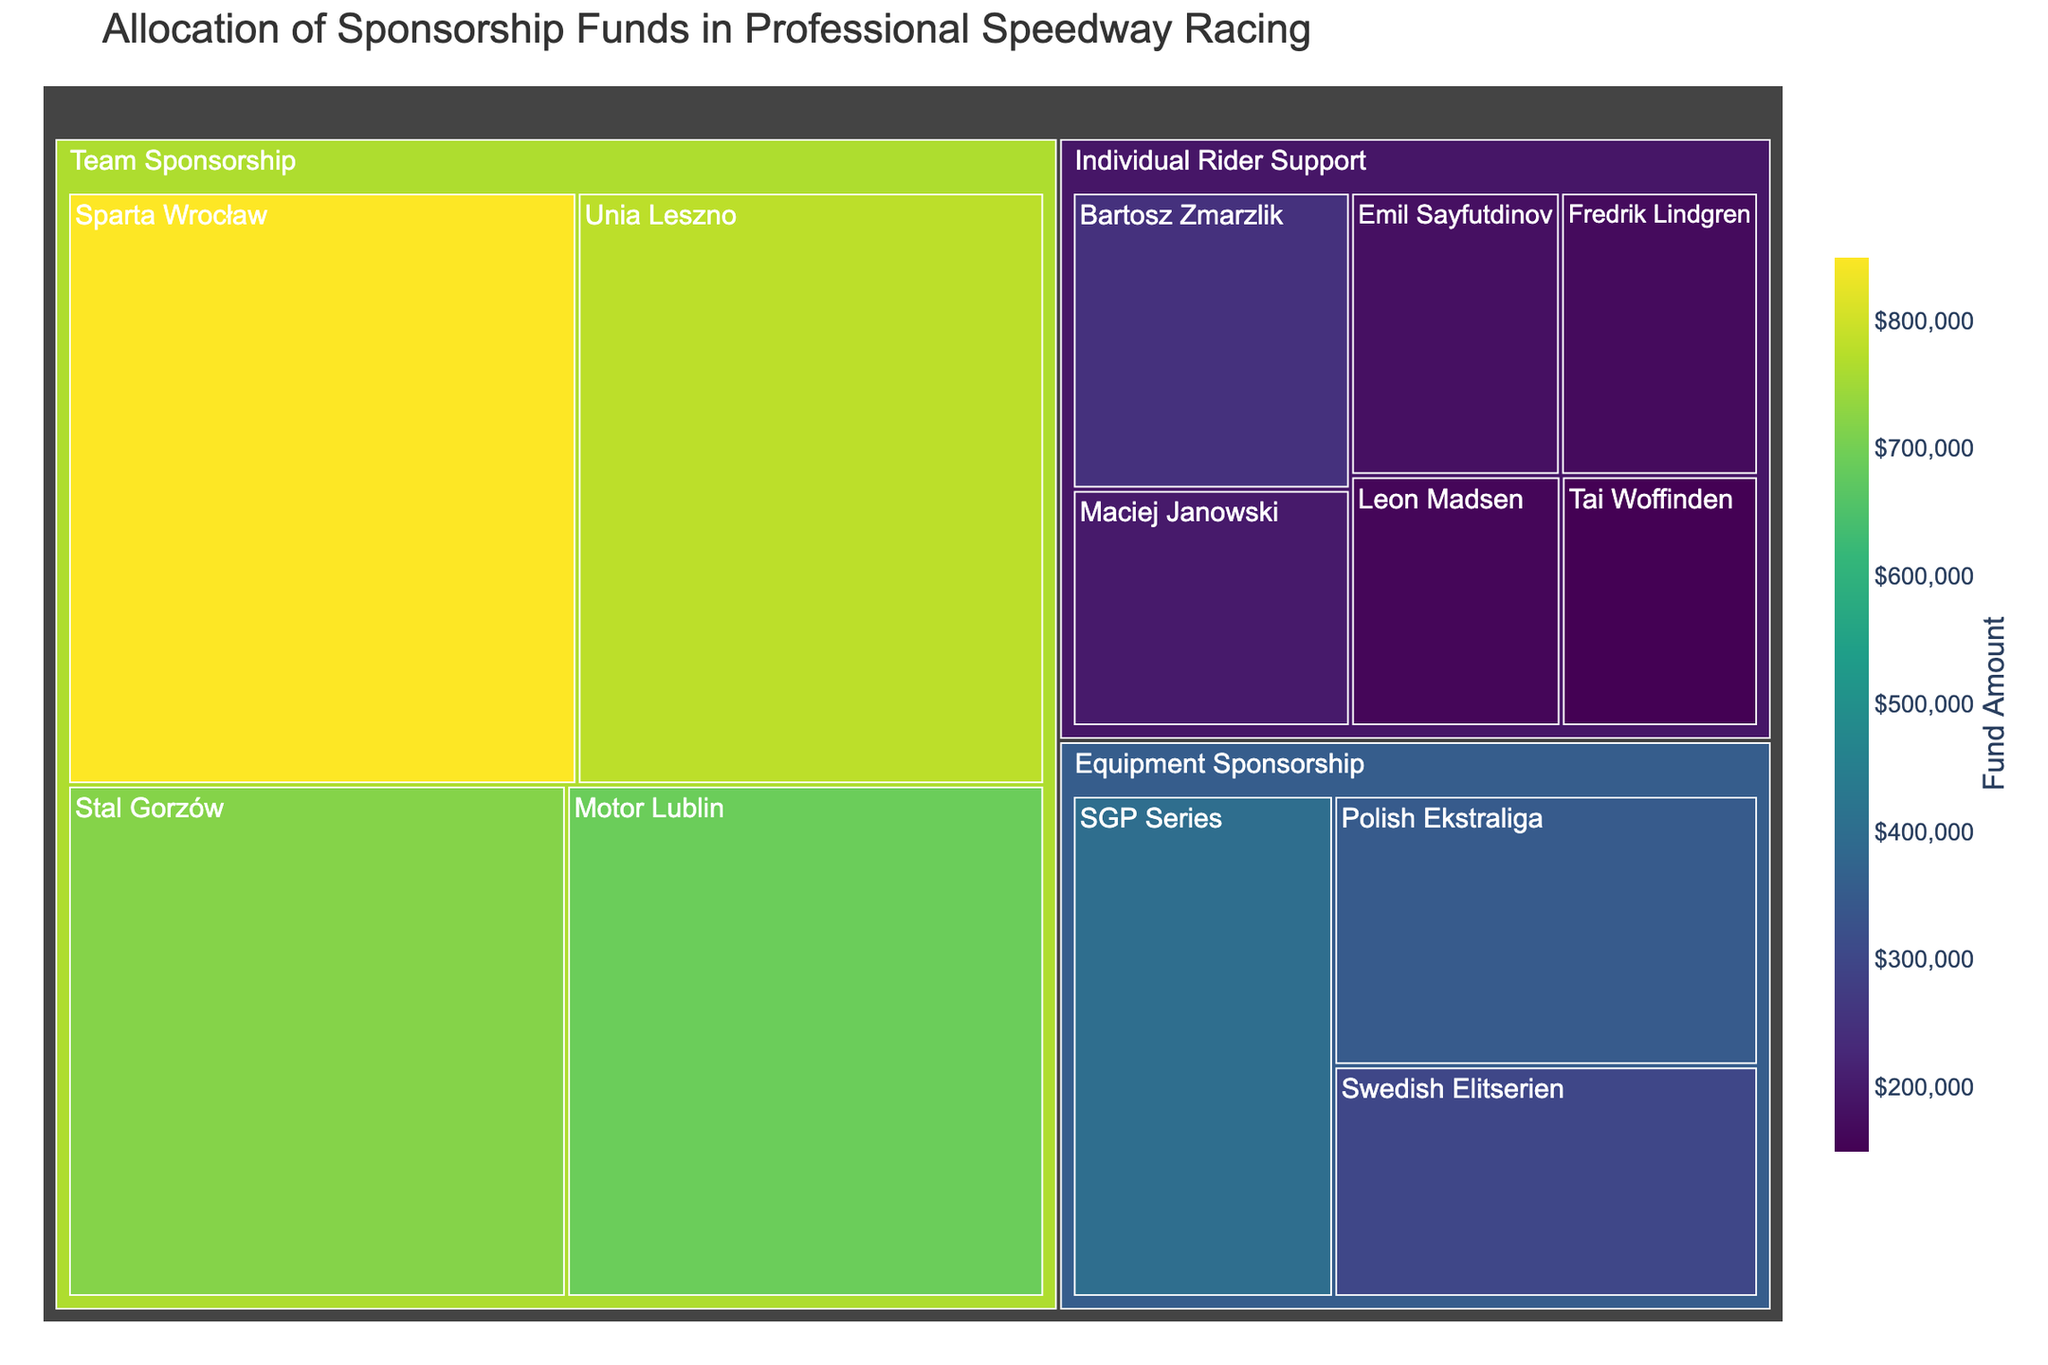Which team received the most sponsorship funds? The treemap shows various sponsorship categories and their subcategories. By looking at the size of the sections, we see that "Sparta Wrocław" under "Team Sponsorship" has the largest segment.
Answer: Sparta Wrocław Which individual rider received the least sponsorship funds? Under the category "Individual Rider Support", the rider with the smallest section is "Tai Woffinden".
Answer: Tai Woffinden What is the total amount allocated for Equipment Sponsorship? To find the total amount for "Equipment Sponsorship", sum up the values for its subcategories: SGP Series ($400,000), Polish Ekstraliga ($350,000), and Swedish Elitserien ($300,000). So, $400,000 + $350,000 + $300,000 = $1,050,000.
Answer: $1,050,000 How does the sponsorship amount for Bartosz Zmarzlik compare to that of Leon Madsen? Check the values for Bartosz Zmarzlik ($250,000) and Leon Madsen ($160,000). By comparing these amounts, Bartosz Zmarzlik received a higher sponsorship amount.
Answer: Bartosz Zmarzlik received more What is the average sponsorship amount given to riders in the "Individual Rider Support" category? Sum up the values for all individual riders: $250,000 + $200,000 + $180,000 + $170,000 + $160,000 + $150,000 = $1,110,000. There are 6 riders, so the average is $1,110,000 / 6 = $185,000.
Answer: $185,000 How do the total funds allocated to team sponsorship compare with individual rider support? Team sponsorship total: $850,000 + $780,000 + $720,000 + $690,000 = $3,040,000. Individual rider support total: $250,000 + $200,000 + $180,000 + $170,000 + $160,000 + $150,000 = $1,110,000. Team sponsorship receives more funds.
Answer: Team sponsorship receives more Which category received the highest total sponsorship funds? Compare the summed totals for each category: Team Sponsorship ($3,040,000), Individual Rider Support ($1,110,000), Equipment Sponsorship ($1,050,000). Team Sponsorship received the highest.
Answer: Team Sponsorship What's the largest single sponsorship amount in the Equipment Sponsorship category? Looking at the segments under Equipment Sponsorship, "SGP Series" has the largest section with $400,000.
Answer: $400,000 If the funds for Motor Lublin were redistributed equally among all individual riders, how much would each rider receive? The funds for Motor Lublin are $690,000. There are 6 individual riders. Dividing the amount by 6 gives $690,000 / 6 = $115,000 per rider.
Answer: $115,000 